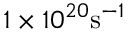Convert formula to latex. <formula><loc_0><loc_0><loc_500><loc_500>1 \times 1 0 ^ { 2 0 } s ^ { - 1 }</formula> 